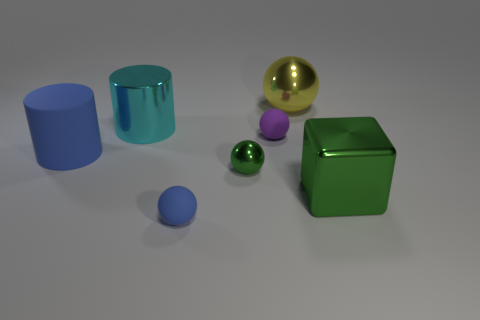Subtract all green balls. How many balls are left? 3 Add 1 big cyan metallic things. How many objects exist? 8 Subtract all blue balls. How many balls are left? 3 Subtract all cylinders. How many objects are left? 5 Subtract 2 balls. How many balls are left? 2 Add 2 blue rubber objects. How many blue rubber objects are left? 4 Add 5 small cyan metal cylinders. How many small cyan metal cylinders exist? 5 Subtract 1 green blocks. How many objects are left? 6 Subtract all purple balls. Subtract all brown blocks. How many balls are left? 3 Subtract all blue balls. How many cyan cylinders are left? 1 